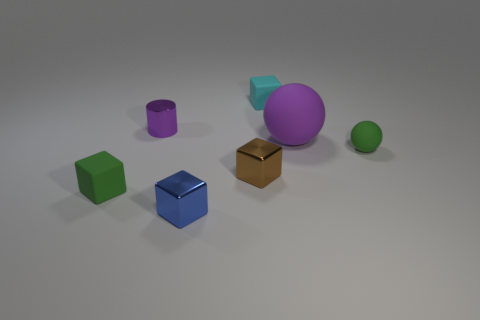There is a green rubber thing to the left of the cyan matte object; what number of tiny rubber cubes are behind it?
Offer a terse response. 1. Do the blue thing and the green matte thing in front of the small brown metallic block have the same size?
Ensure brevity in your answer.  Yes. Is the cylinder the same size as the green cube?
Your response must be concise. Yes. Are there any shiny blocks that have the same size as the purple matte sphere?
Ensure brevity in your answer.  No. There is a sphere on the right side of the big thing; what is its material?
Ensure brevity in your answer.  Rubber. There is a cube that is made of the same material as the cyan object; what is its color?
Ensure brevity in your answer.  Green. What number of metallic objects are either large red blocks or cyan things?
Ensure brevity in your answer.  0. What is the shape of the brown metal object that is the same size as the cyan object?
Ensure brevity in your answer.  Cube. What number of things are either purple things that are left of the tiny cyan rubber cube or cylinders that are left of the large purple matte ball?
Provide a succinct answer. 1. There is a sphere that is the same size as the green rubber block; what material is it?
Offer a very short reply. Rubber. 